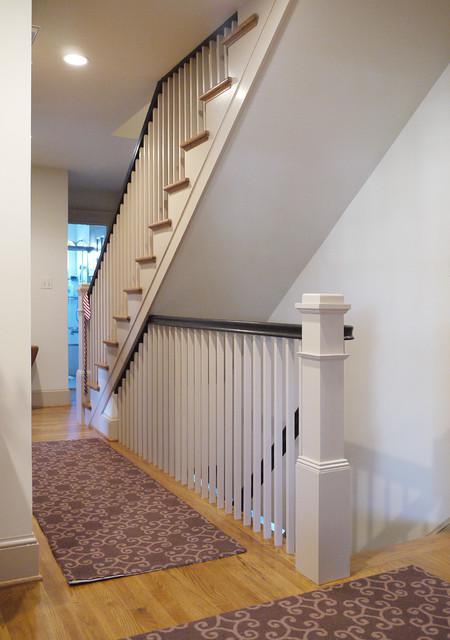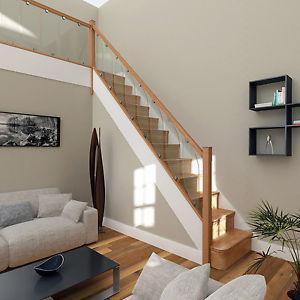The first image is the image on the left, the second image is the image on the right. For the images displayed, is the sentence "Each image shows a staircase that is open underneath and ascends in one diagonal line, without turning and with no upper railed landing." factually correct? Answer yes or no. No. The first image is the image on the left, the second image is the image on the right. Given the left and right images, does the statement "In at least one image there is a staircase facing left with three separate glass panels held up by a light brown rail." hold true? Answer yes or no. No. 